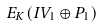<formula> <loc_0><loc_0><loc_500><loc_500>E _ { K } ( I V _ { 1 } \oplus P _ { 1 } )</formula> 